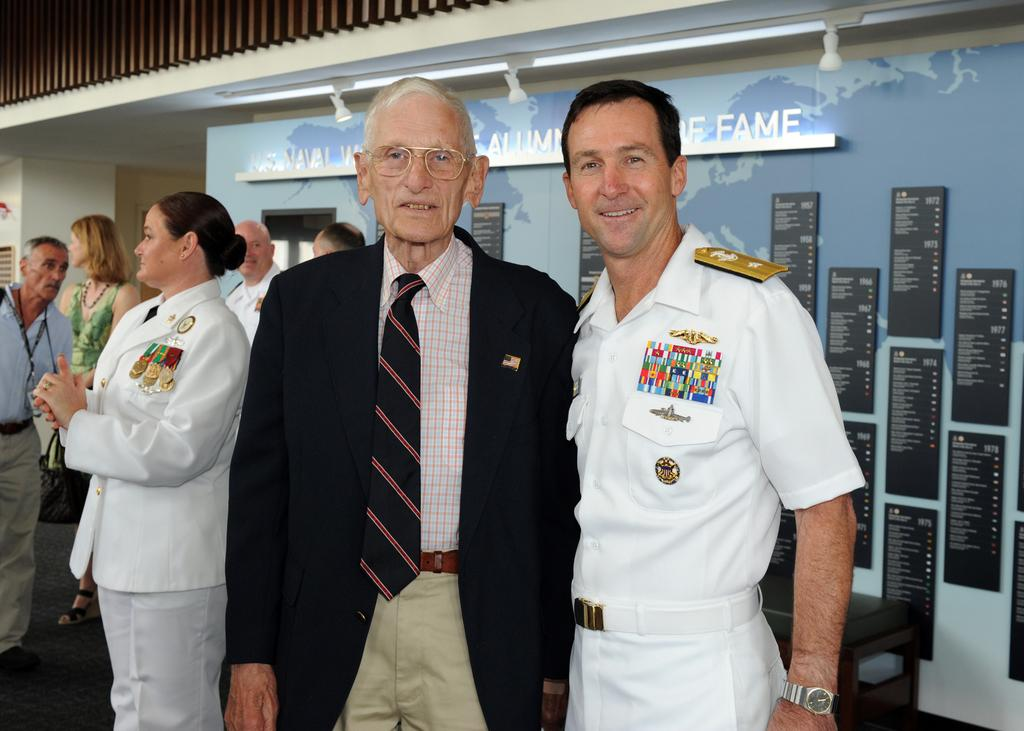Provide a one-sentence caption for the provided image. An elderly man poses for a picture with a man in uniform in front of a naval hall of fame sign. 